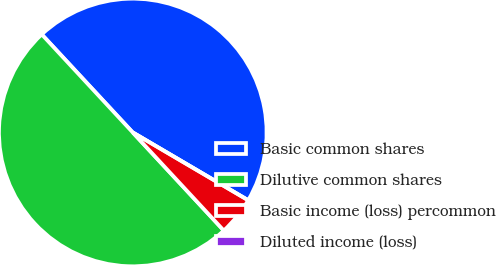Convert chart to OTSL. <chart><loc_0><loc_0><loc_500><loc_500><pie_chart><fcel>Basic common shares<fcel>Dilutive common shares<fcel>Basic income (loss) percommon<fcel>Diluted income (loss)<nl><fcel>45.36%<fcel>50.0%<fcel>4.64%<fcel>0.0%<nl></chart> 